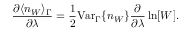<formula> <loc_0><loc_0><loc_500><loc_500>\frac { \partial \langle n _ { W } \rangle _ { \Gamma } } { \partial \lambda } = \frac { 1 } { 2 } V a r _ { \Gamma } \{ n _ { W } \} \frac { \partial } { \partial \lambda } \ln [ W ] .</formula> 